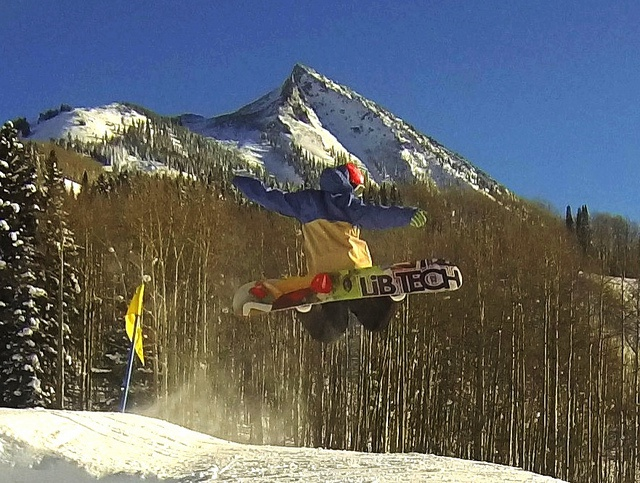Describe the objects in this image and their specific colors. I can see people in blue, black, and olive tones and snowboard in blue, black, olive, maroon, and tan tones in this image. 